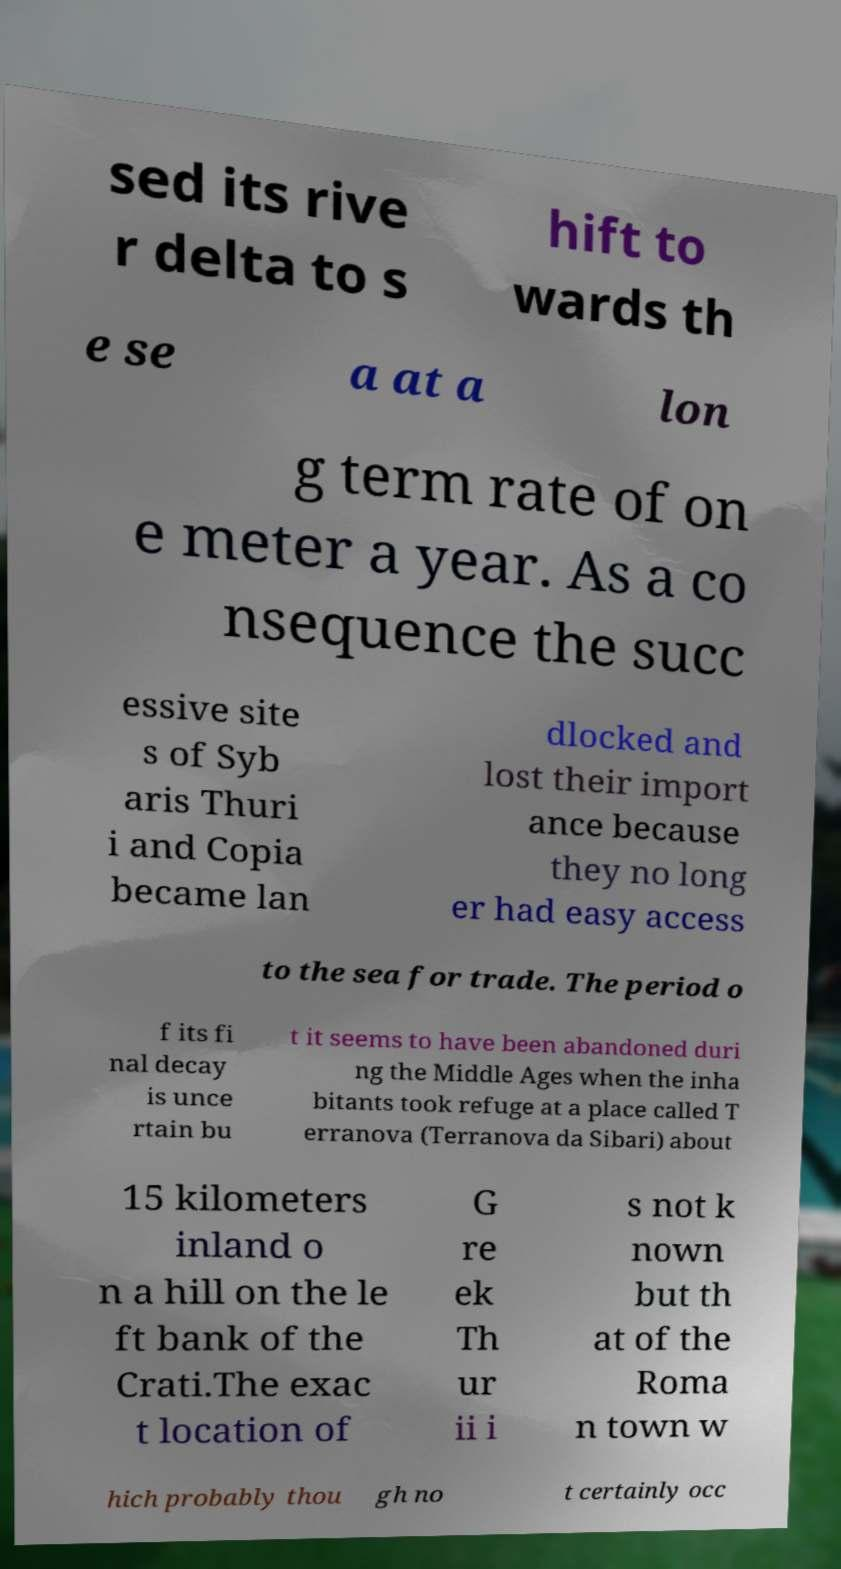There's text embedded in this image that I need extracted. Can you transcribe it verbatim? sed its rive r delta to s hift to wards th e se a at a lon g term rate of on e meter a year. As a co nsequence the succ essive site s of Syb aris Thuri i and Copia became lan dlocked and lost their import ance because they no long er had easy access to the sea for trade. The period o f its fi nal decay is unce rtain bu t it seems to have been abandoned duri ng the Middle Ages when the inha bitants took refuge at a place called T erranova (Terranova da Sibari) about 15 kilometers inland o n a hill on the le ft bank of the Crati.The exac t location of G re ek Th ur ii i s not k nown but th at of the Roma n town w hich probably thou gh no t certainly occ 